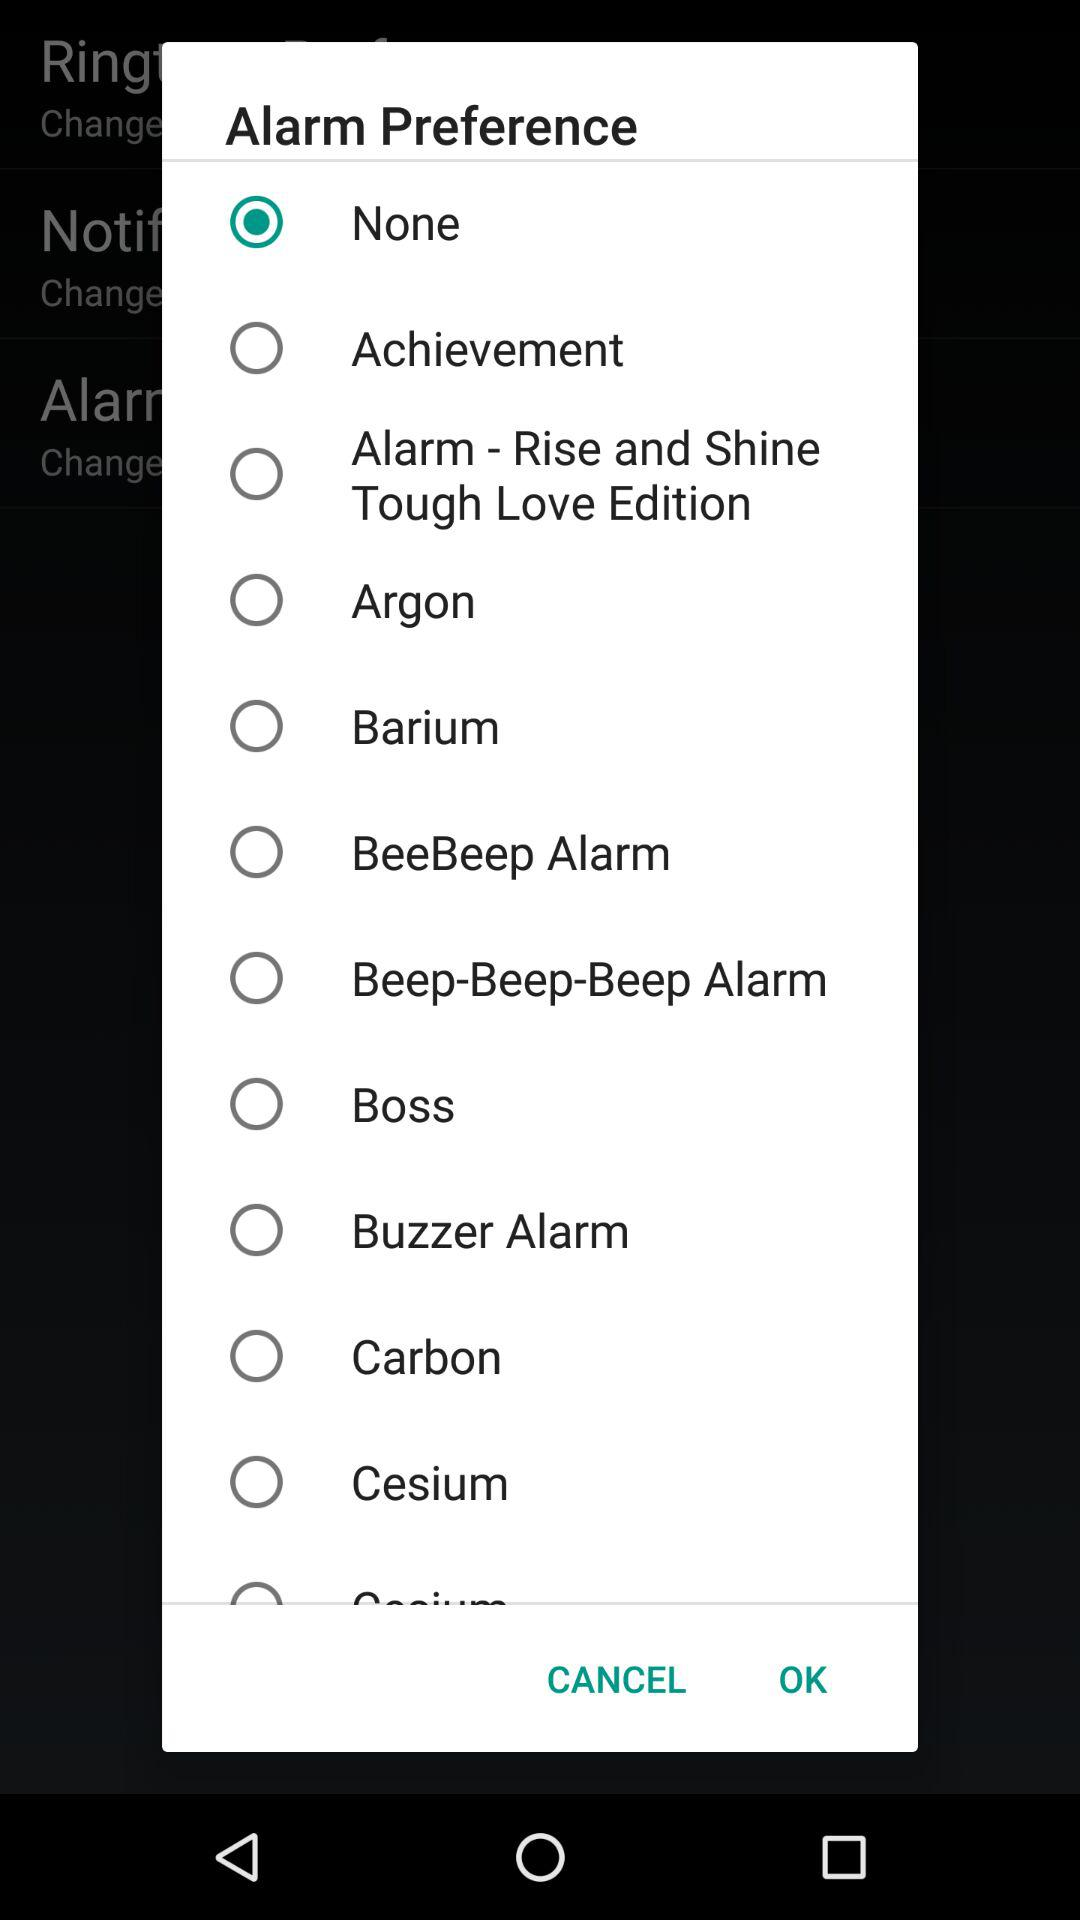Which option is selected? The selected option is "None". 